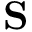<formula> <loc_0><loc_0><loc_500><loc_500>\mathbf S</formula> 